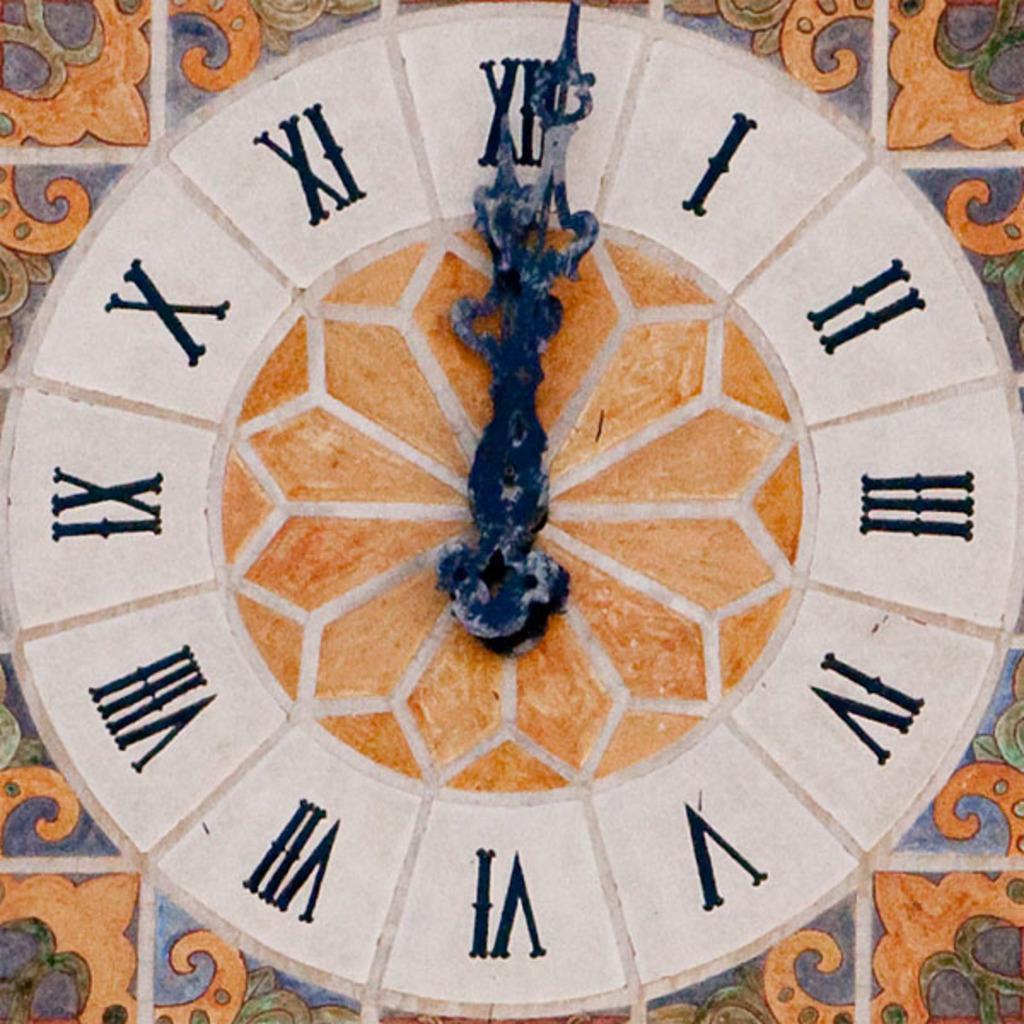How would you summarize this image in a sentence or two? In this image I can see a clock attached to the wall. 